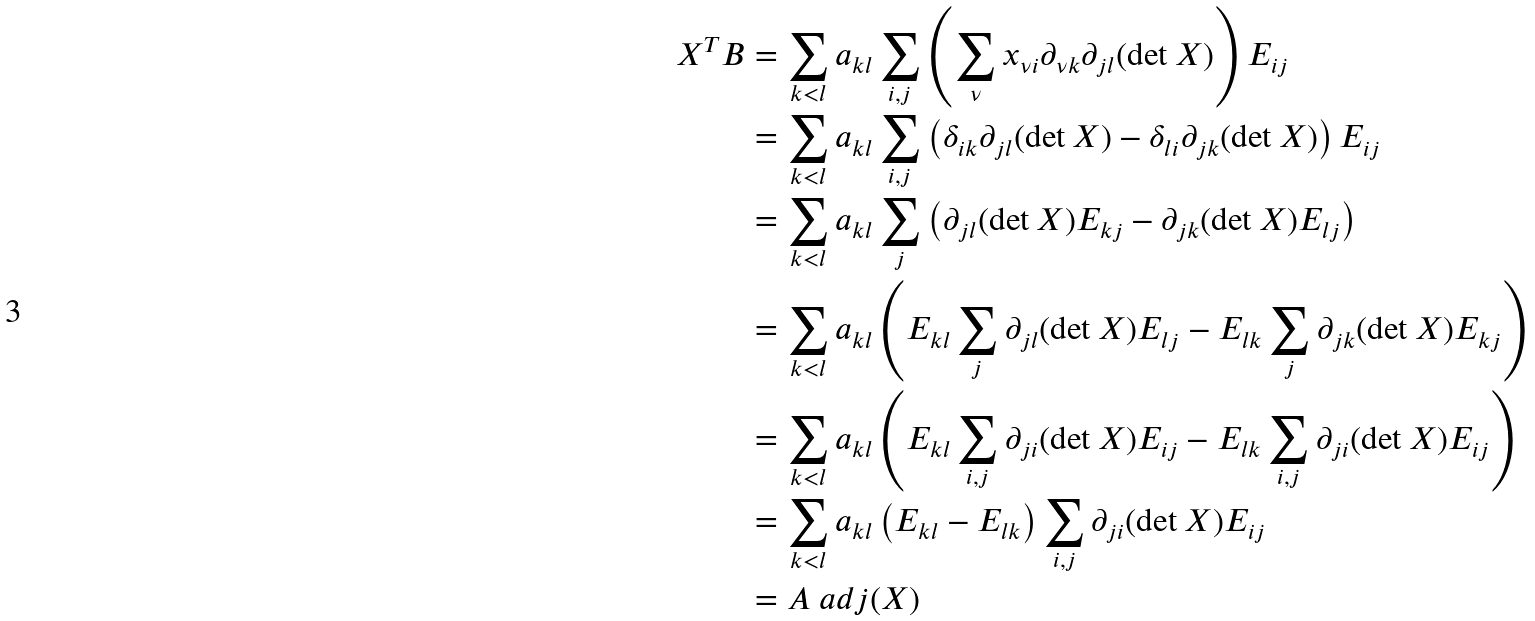<formula> <loc_0><loc_0><loc_500><loc_500>X ^ { T } B & = \sum _ { k < l } a _ { k l } \sum _ { i , j } \left ( \sum _ { \nu } x _ { \nu i } \partial _ { \nu k } \partial _ { j l } ( \det X ) \right ) E _ { i j } \\ & = \sum _ { k < l } a _ { k l } \sum _ { i , j } \left ( \delta _ { i k } \partial _ { j l } ( \det X ) - \delta _ { l i } \partial _ { j k } ( \det X ) \right ) E _ { i j } \\ & = \sum _ { k < l } a _ { k l } \sum _ { j } \left ( \partial _ { j l } ( \det X ) E _ { k j } - \partial _ { j k } ( \det X ) E _ { l j } \right ) \\ & = \sum _ { k < l } a _ { k l } \left ( E _ { k l } \sum _ { j } \partial _ { j l } ( \det X ) E _ { l j } - E _ { l k } \sum _ { j } \partial _ { j k } ( \det X ) E _ { k j } \right ) \\ & = \sum _ { k < l } a _ { k l } \left ( E _ { k l } \sum _ { i , j } \partial _ { j i } ( \det X ) E _ { i j } - E _ { l k } \sum _ { i , j } \partial _ { j i } ( \det X ) E _ { i j } \right ) \\ & = \sum _ { k < l } a _ { k l } \left ( E _ { k l } - E _ { l k } \right ) \sum _ { i , j } \partial _ { j i } ( \det X ) E _ { i j } \\ & = A \ a d j ( X )</formula> 